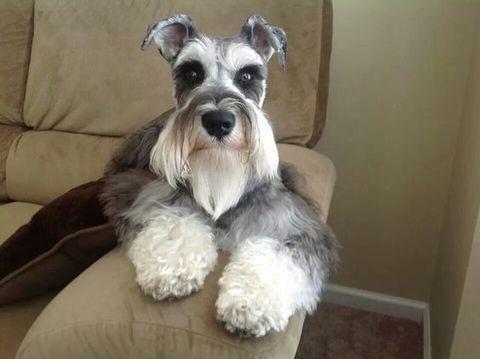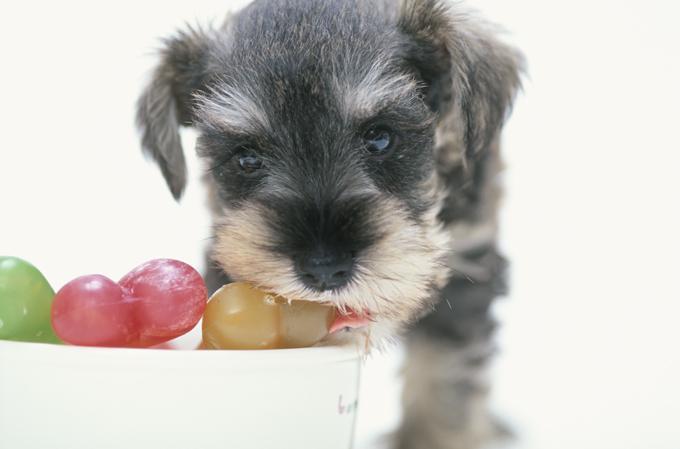The first image is the image on the left, the second image is the image on the right. Analyze the images presented: Is the assertion "There is a colorful dog toy in the image on the right" valid? Answer yes or no. Yes. The first image is the image on the left, the second image is the image on the right. Given the left and right images, does the statement "There are two dogs inside." hold true? Answer yes or no. Yes. 